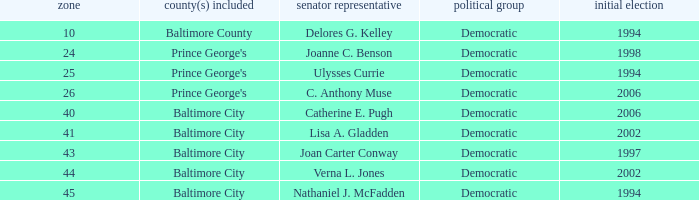What district for ulysses currie? 25.0. 